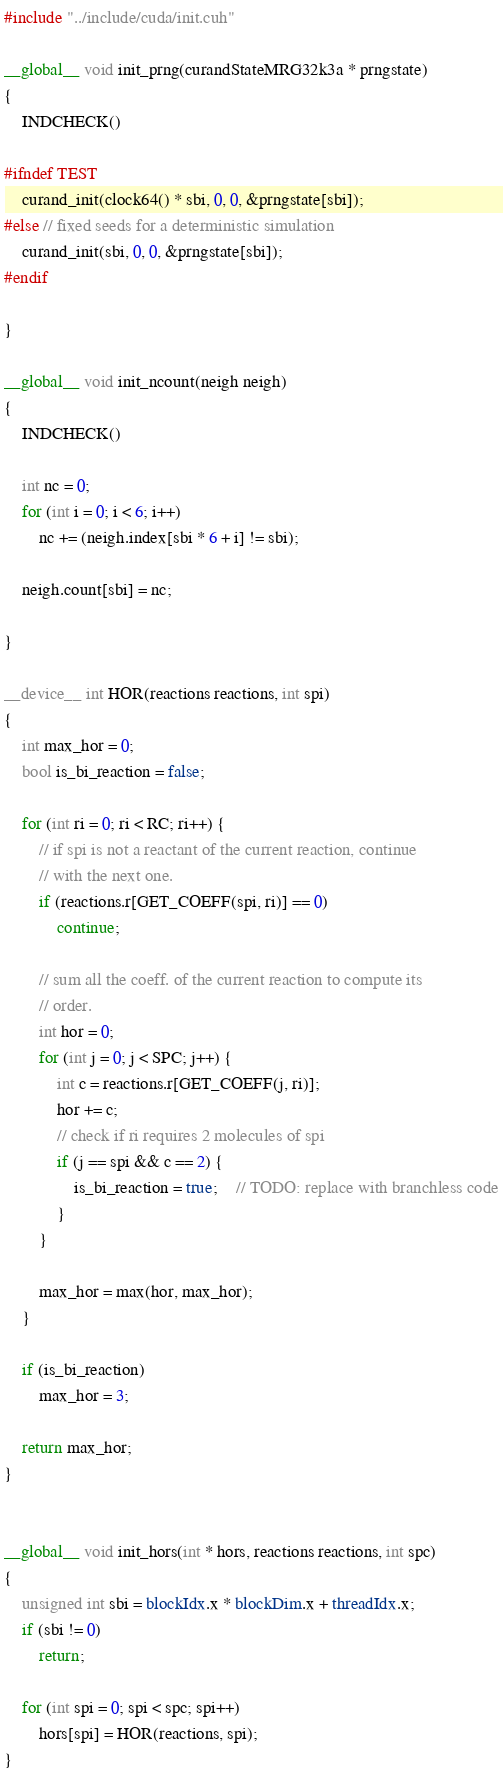<code> <loc_0><loc_0><loc_500><loc_500><_Cuda_>#include "../include/cuda/init.cuh"

__global__ void init_prng(curandStateMRG32k3a * prngstate)
{
	INDCHECK()

#ifndef TEST
	curand_init(clock64() * sbi, 0, 0, &prngstate[sbi]);
#else // fixed seeds for a deterministic simulation
	curand_init(sbi, 0, 0, &prngstate[sbi]);
#endif

}

__global__ void init_ncount(neigh neigh)
{
	INDCHECK()

	int nc = 0;
	for (int i = 0; i < 6; i++)
		nc += (neigh.index[sbi * 6 + i] != sbi);
	
	neigh.count[sbi] = nc;

}

__device__ int HOR(reactions reactions, int spi)
{
	int max_hor = 0;
	bool is_bi_reaction = false;

	for (int ri = 0; ri < RC; ri++) {
		// if spi is not a reactant of the current reaction, continue
		// with the next one.
		if (reactions.r[GET_COEFF(spi, ri)] == 0)
			continue;

		// sum all the coeff. of the current reaction to compute its
		// order.
		int hor = 0;
		for (int j = 0; j < SPC; j++) {
			int c = reactions.r[GET_COEFF(j, ri)];
			hor += c;
			// check if ri requires 2 molecules of spi
			if (j == spi && c == 2) {
				is_bi_reaction = true;    // TODO: replace with branchless code
			}
		}

		max_hor = max(hor, max_hor);
	}

	if (is_bi_reaction)
		max_hor = 3;

	return max_hor;
}


__global__ void init_hors(int * hors, reactions reactions, int spc)
{
	unsigned int sbi = blockIdx.x * blockDim.x + threadIdx.x;
	if (sbi != 0)
		return;

	for (int spi = 0; spi < spc; spi++)
		hors[spi] = HOR(reactions, spi);
}


</code> 